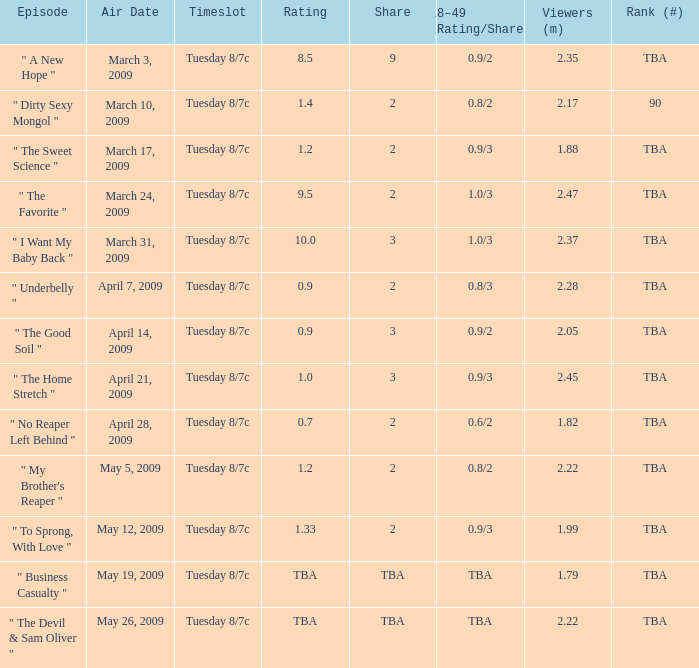What is the grade of the show ranked tba, televised on april 21, 2009? 1.0. 